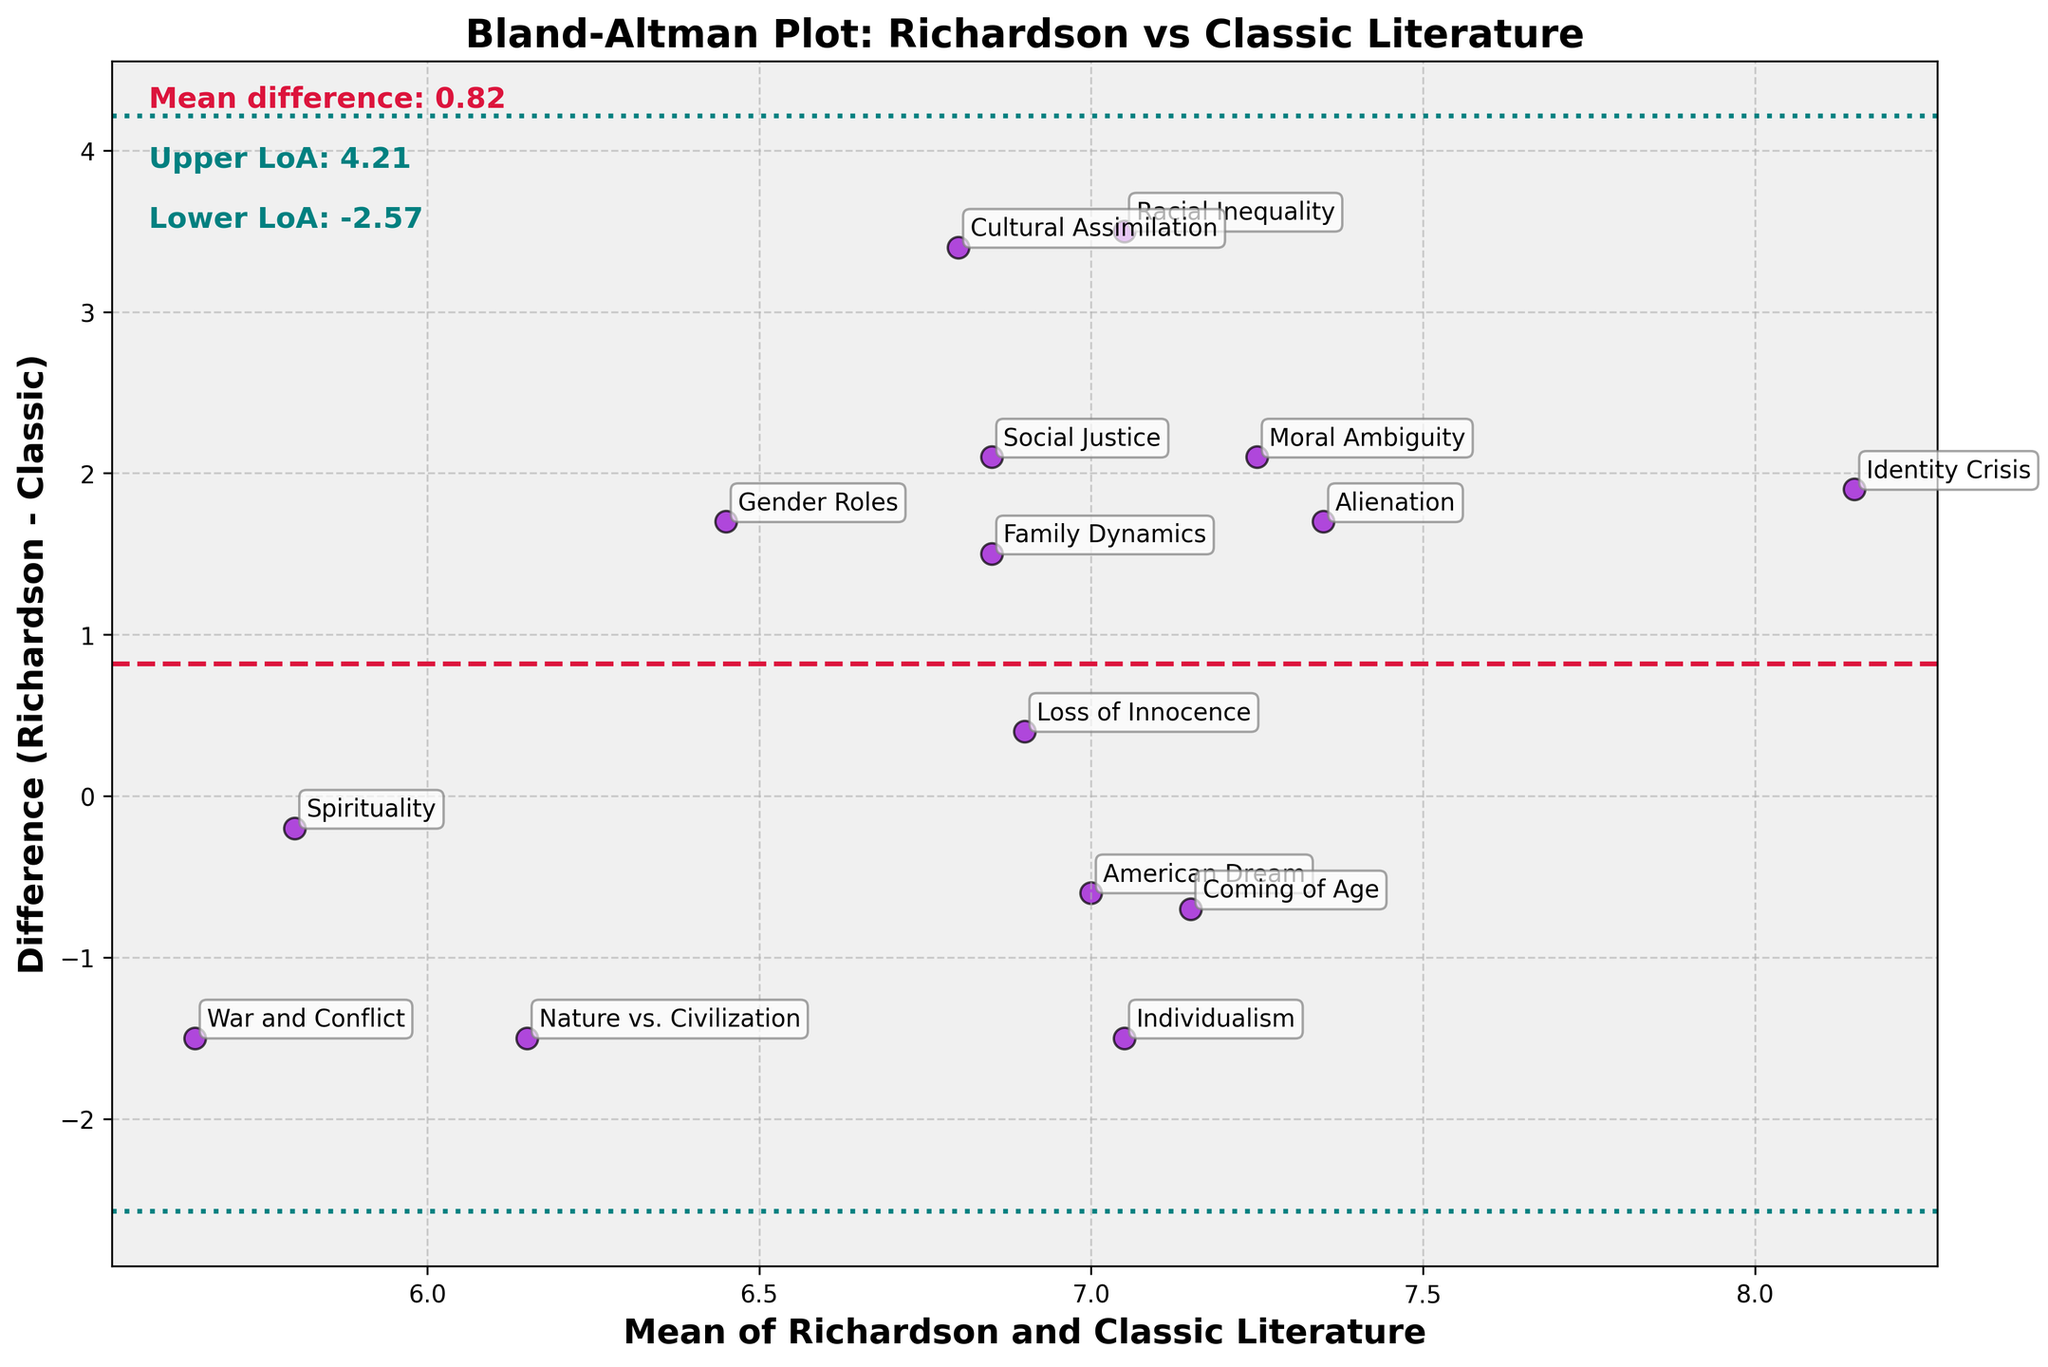What is the title of the plot? The title of the plot is usually located at the top and is displayed in bold. From the data provided, the title of the plot is "Bland-Altman Plot: Richardson vs Classic Literature".
Answer: Bland-Altman Plot: Richardson vs Classic Literature How many themes are analyzed in the plot? To determine the number of themes analyzed, you count the number of data points (dots) in the plot. Each data point represents a theme. From the provided data, there are 15 themes.
Answer: 15 What color represents the scatter points in the plot? The color used for the scatter points can be identified by observing the plot. According to the code, the scatter points are colored 'darkviolet'.
Answer: Darkviolet What does the dashed crimson line represent? In Bland–Altman plots, a dashed line often represents the mean difference between two sets of measurements. From the provided code, the crimson line represents the mean difference between Richardson and Classic Literature.
Answer: Mean difference Which theme has the highest mean frequency? The theme with the highest mean frequency is determined by calculating (Richardson_Frequency + Classic_Literature_Frequency)/2 for each theme and identifying the maximum value. The theme "Identity Crisis" has the highest mean frequency.
Answer: Identity Crisis What are the values for the limits of agreement? The limits of agreement are the mean difference plus and minus 1.96 times the standard deviation of the differences. From the code, the limits are calculated and shown in the plot as the two teal lines. Upper Limit: 2.54, Lower Limit: -0.42.
Answer: Upper Limit: 2.54, Lower Limit: -0.42 What theme shows the largest positive difference between Richardson and Classic Literature? To find this, we look for the theme where Richardson_Frequency - Classic_Literature_Frequency is the largest. The theme "Racial Inequality" shows the largest positive difference (8.8 - 5.3 = 3.5).
Answer: Racial Inequality Is there any theme where the frequency in Richardson's writing is less than that in Classic Literature? This requires looking for any theme where Richardson_Frequency < Classic_Literature_Frequency. "American Dream," "Nature vs. Civilization," "Individualism," and "War and Conflict" satisfy this condition.
Answer: Yes, there are themes with lower frequency What is the mean difference between Richardson and Classic Literature frequencies? The mean difference is the average difference between Richardson_Frequency and Classic_Literature_Frequency. This value is shown in the plot and calculated as 1.06.
Answer: 1.06 Between which values is the difference of most themes found? The majority of the points lie between the limits of agreement: -0.42 and 2.54. Most themes' differences fall between these values.
Answer: -0.42 and 2.54 